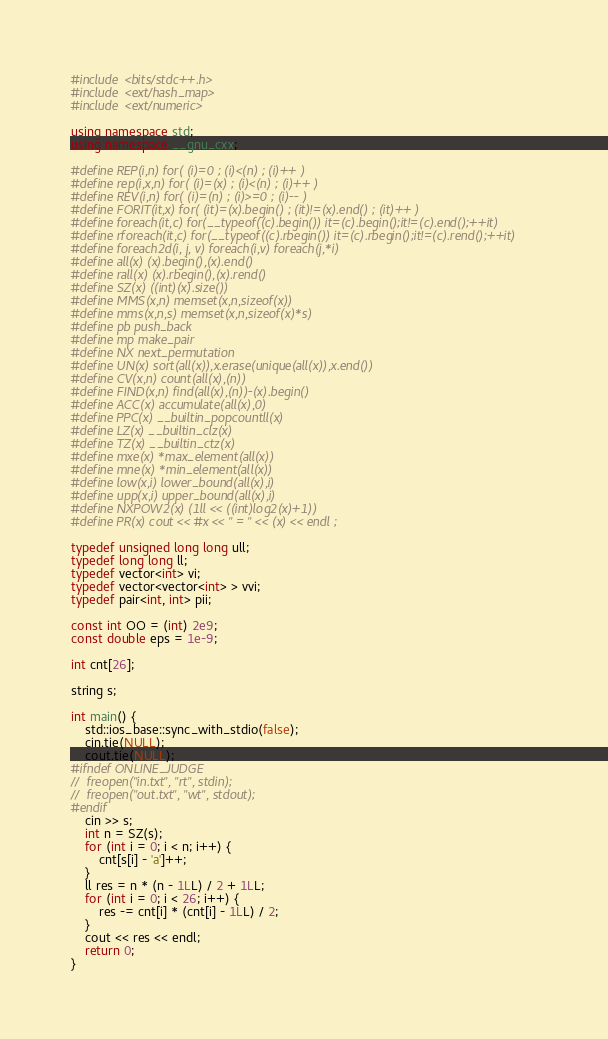Convert code to text. <code><loc_0><loc_0><loc_500><loc_500><_C++_>#include <bits/stdc++.h>
#include <ext/hash_map>
#include <ext/numeric>

using namespace std;
using namespace __gnu_cxx;

#define REP(i,n) for( (i)=0 ; (i)<(n) ; (i)++ )
#define rep(i,x,n) for( (i)=(x) ; (i)<(n) ; (i)++ )
#define REV(i,n) for( (i)=(n) ; (i)>=0 ; (i)-- )
#define FORIT(it,x) for( (it)=(x).begin() ; (it)!=(x).end() ; (it)++ )
#define foreach(it,c) for(__typeof((c).begin()) it=(c).begin();it!=(c).end();++it)
#define rforeach(it,c) for(__typeof((c).rbegin()) it=(c).rbegin();it!=(c).rend();++it)
#define foreach2d(i, j, v) foreach(i,v) foreach(j,*i)
#define all(x) (x).begin(),(x).end()
#define rall(x) (x).rbegin(),(x).rend()
#define SZ(x) ((int)(x).size())
#define MMS(x,n) memset(x,n,sizeof(x))
#define mms(x,n,s) memset(x,n,sizeof(x)*s)
#define pb push_back
#define mp make_pair
#define NX next_permutation
#define UN(x) sort(all(x)),x.erase(unique(all(x)),x.end())
#define CV(x,n) count(all(x),(n))
#define FIND(x,n) find(all(x),(n))-(x).begin()
#define ACC(x) accumulate(all(x),0)
#define PPC(x) __builtin_popcountll(x)
#define LZ(x) __builtin_clz(x)
#define TZ(x) __builtin_ctz(x)
#define mxe(x) *max_element(all(x))
#define mne(x) *min_element(all(x))
#define low(x,i) lower_bound(all(x),i)
#define upp(x,i) upper_bound(all(x),i)
#define NXPOW2(x) (1ll << ((int)log2(x)+1))
#define PR(x) cout << #x << " = " << (x) << endl ;

typedef unsigned long long ull;
typedef long long ll;
typedef vector<int> vi;
typedef vector<vector<int> > vvi;
typedef pair<int, int> pii;

const int OO = (int) 2e9;
const double eps = 1e-9;

int cnt[26];

string s;

int main() {
	std::ios_base::sync_with_stdio(false);
	cin.tie(NULL);
	cout.tie(NULL);
#ifndef ONLINE_JUDGE
//	freopen("in.txt", "rt", stdin);
//	freopen("out.txt", "wt", stdout);
#endif
	cin >> s;
	int n = SZ(s);
	for (int i = 0; i < n; i++) {
		cnt[s[i] - 'a']++;
	}
	ll res = n * (n - 1LL) / 2 + 1LL;
	for (int i = 0; i < 26; i++) {
		res -= cnt[i] * (cnt[i] - 1LL) / 2;
	}
	cout << res << endl;
	return 0;
}
</code> 